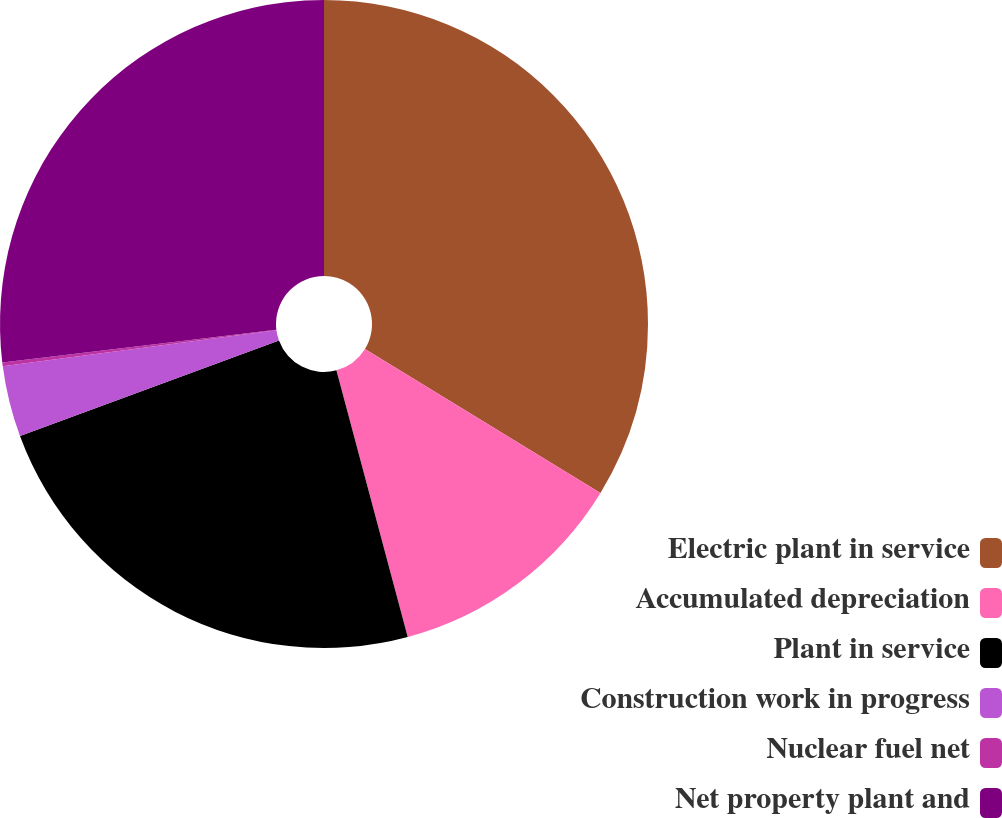Convert chart. <chart><loc_0><loc_0><loc_500><loc_500><pie_chart><fcel>Electric plant in service<fcel>Accumulated depreciation<fcel>Plant in service<fcel>Construction work in progress<fcel>Nuclear fuel net<fcel>Net property plant and<nl><fcel>33.73%<fcel>12.11%<fcel>23.54%<fcel>3.54%<fcel>0.19%<fcel>26.89%<nl></chart> 